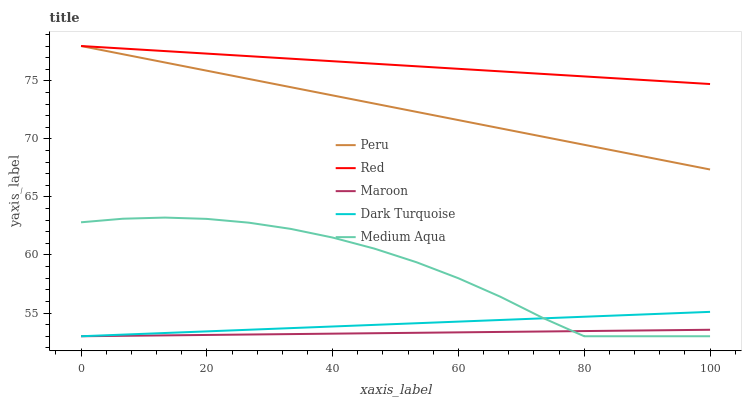Does Maroon have the minimum area under the curve?
Answer yes or no. Yes. Does Red have the maximum area under the curve?
Answer yes or no. Yes. Does Medium Aqua have the minimum area under the curve?
Answer yes or no. No. Does Medium Aqua have the maximum area under the curve?
Answer yes or no. No. Is Maroon the smoothest?
Answer yes or no. Yes. Is Medium Aqua the roughest?
Answer yes or no. Yes. Is Red the smoothest?
Answer yes or no. No. Is Red the roughest?
Answer yes or no. No. Does Maroon have the lowest value?
Answer yes or no. Yes. Does Red have the lowest value?
Answer yes or no. No. Does Peru have the highest value?
Answer yes or no. Yes. Does Medium Aqua have the highest value?
Answer yes or no. No. Is Medium Aqua less than Peru?
Answer yes or no. Yes. Is Peru greater than Maroon?
Answer yes or no. Yes. Does Maroon intersect Dark Turquoise?
Answer yes or no. Yes. Is Maroon less than Dark Turquoise?
Answer yes or no. No. Is Maroon greater than Dark Turquoise?
Answer yes or no. No. Does Medium Aqua intersect Peru?
Answer yes or no. No. 